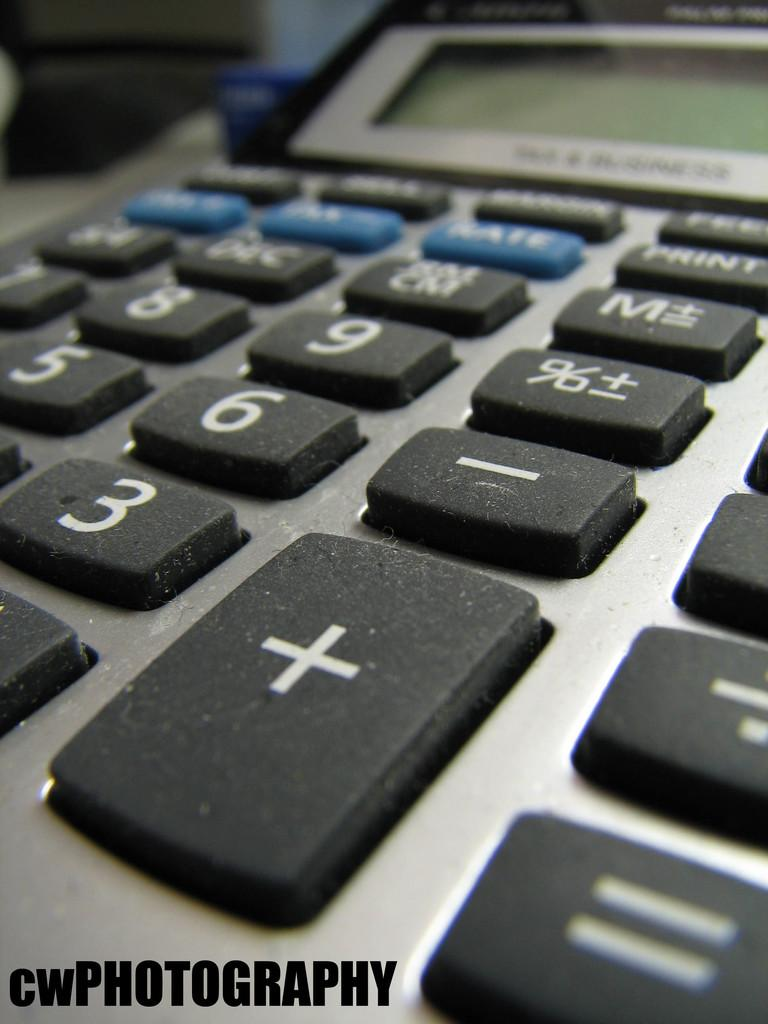Provide a one-sentence caption for the provided image. a calculator with the label CWPHOTOGRAPHY at the bottom of it. 